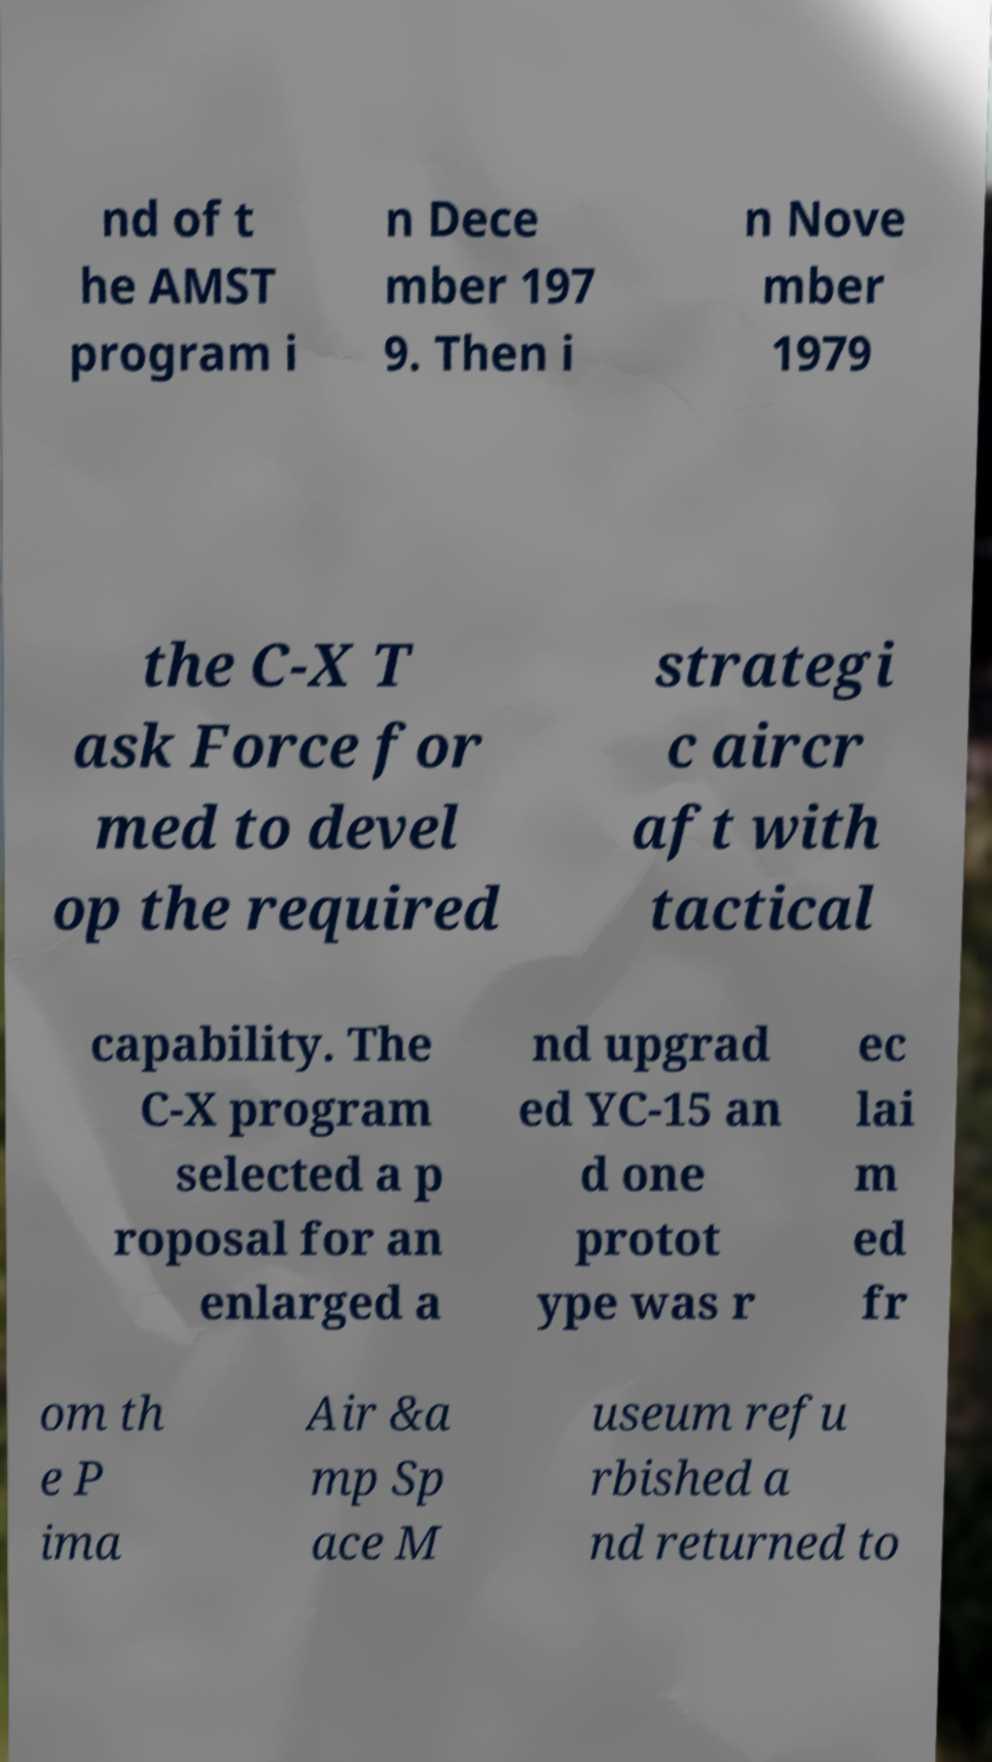There's text embedded in this image that I need extracted. Can you transcribe it verbatim? nd of t he AMST program i n Dece mber 197 9. Then i n Nove mber 1979 the C-X T ask Force for med to devel op the required strategi c aircr aft with tactical capability. The C-X program selected a p roposal for an enlarged a nd upgrad ed YC-15 an d one protot ype was r ec lai m ed fr om th e P ima Air &a mp Sp ace M useum refu rbished a nd returned to 